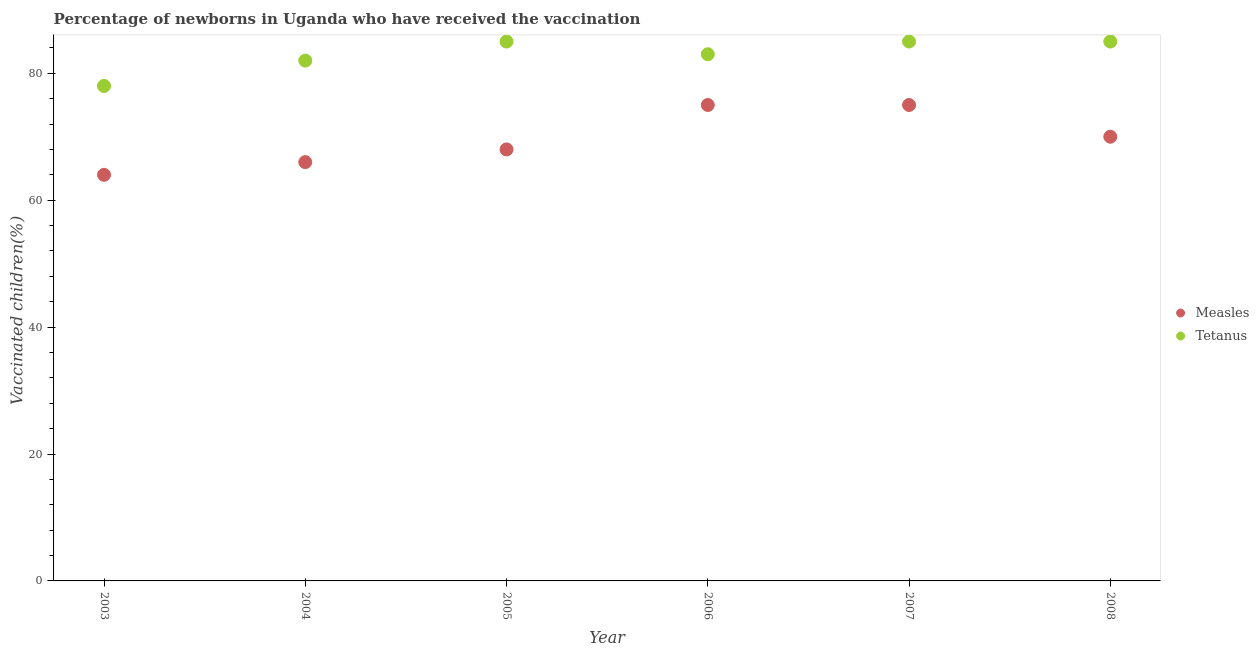How many different coloured dotlines are there?
Ensure brevity in your answer.  2. Is the number of dotlines equal to the number of legend labels?
Ensure brevity in your answer.  Yes. What is the percentage of newborns who received vaccination for tetanus in 2008?
Give a very brief answer. 85. Across all years, what is the maximum percentage of newborns who received vaccination for tetanus?
Offer a terse response. 85. Across all years, what is the minimum percentage of newborns who received vaccination for tetanus?
Offer a very short reply. 78. In which year was the percentage of newborns who received vaccination for measles maximum?
Your answer should be compact. 2006. What is the total percentage of newborns who received vaccination for tetanus in the graph?
Your answer should be compact. 498. What is the difference between the percentage of newborns who received vaccination for measles in 2003 and that in 2005?
Offer a very short reply. -4. What is the difference between the percentage of newborns who received vaccination for measles in 2003 and the percentage of newborns who received vaccination for tetanus in 2006?
Make the answer very short. -19. What is the average percentage of newborns who received vaccination for measles per year?
Make the answer very short. 69.67. In the year 2006, what is the difference between the percentage of newborns who received vaccination for measles and percentage of newborns who received vaccination for tetanus?
Make the answer very short. -8. In how many years, is the percentage of newborns who received vaccination for tetanus greater than 76 %?
Your answer should be very brief. 6. What is the ratio of the percentage of newborns who received vaccination for measles in 2007 to that in 2008?
Your answer should be compact. 1.07. What is the difference between the highest and the second highest percentage of newborns who received vaccination for measles?
Provide a succinct answer. 0. What is the difference between the highest and the lowest percentage of newborns who received vaccination for measles?
Provide a short and direct response. 11. In how many years, is the percentage of newborns who received vaccination for tetanus greater than the average percentage of newborns who received vaccination for tetanus taken over all years?
Keep it short and to the point. 3. Does the percentage of newborns who received vaccination for tetanus monotonically increase over the years?
Ensure brevity in your answer.  No. Is the percentage of newborns who received vaccination for measles strictly greater than the percentage of newborns who received vaccination for tetanus over the years?
Ensure brevity in your answer.  No. Is the percentage of newborns who received vaccination for tetanus strictly less than the percentage of newborns who received vaccination for measles over the years?
Your answer should be compact. No. How many years are there in the graph?
Offer a terse response. 6. Does the graph contain any zero values?
Keep it short and to the point. No. Does the graph contain grids?
Keep it short and to the point. No. How many legend labels are there?
Ensure brevity in your answer.  2. What is the title of the graph?
Give a very brief answer. Percentage of newborns in Uganda who have received the vaccination. Does "Private consumption" appear as one of the legend labels in the graph?
Make the answer very short. No. What is the label or title of the X-axis?
Keep it short and to the point. Year. What is the label or title of the Y-axis?
Keep it short and to the point. Vaccinated children(%)
. What is the Vaccinated children(%)
 in Measles in 2003?
Ensure brevity in your answer.  64. What is the Vaccinated children(%)
 in Tetanus in 2003?
Make the answer very short. 78. What is the Vaccinated children(%)
 of Measles in 2004?
Your answer should be very brief. 66. What is the Vaccinated children(%)
 in Measles in 2006?
Keep it short and to the point. 75. Across all years, what is the maximum Vaccinated children(%)
 of Measles?
Provide a short and direct response. 75. Across all years, what is the minimum Vaccinated children(%)
 of Measles?
Ensure brevity in your answer.  64. What is the total Vaccinated children(%)
 of Measles in the graph?
Keep it short and to the point. 418. What is the total Vaccinated children(%)
 in Tetanus in the graph?
Offer a terse response. 498. What is the difference between the Vaccinated children(%)
 in Measles in 2003 and that in 2005?
Offer a terse response. -4. What is the difference between the Vaccinated children(%)
 in Tetanus in 2003 and that in 2005?
Offer a very short reply. -7. What is the difference between the Vaccinated children(%)
 in Measles in 2003 and that in 2006?
Your response must be concise. -11. What is the difference between the Vaccinated children(%)
 of Measles in 2003 and that in 2007?
Make the answer very short. -11. What is the difference between the Vaccinated children(%)
 in Tetanus in 2003 and that in 2007?
Your answer should be very brief. -7. What is the difference between the Vaccinated children(%)
 in Measles in 2003 and that in 2008?
Give a very brief answer. -6. What is the difference between the Vaccinated children(%)
 of Tetanus in 2003 and that in 2008?
Provide a succinct answer. -7. What is the difference between the Vaccinated children(%)
 in Measles in 2004 and that in 2005?
Your response must be concise. -2. What is the difference between the Vaccinated children(%)
 in Measles in 2004 and that in 2007?
Ensure brevity in your answer.  -9. What is the difference between the Vaccinated children(%)
 of Tetanus in 2004 and that in 2007?
Make the answer very short. -3. What is the difference between the Vaccinated children(%)
 in Tetanus in 2004 and that in 2008?
Make the answer very short. -3. What is the difference between the Vaccinated children(%)
 of Measles in 2005 and that in 2006?
Make the answer very short. -7. What is the difference between the Vaccinated children(%)
 in Tetanus in 2005 and that in 2007?
Your response must be concise. 0. What is the difference between the Vaccinated children(%)
 of Tetanus in 2006 and that in 2007?
Your response must be concise. -2. What is the difference between the Vaccinated children(%)
 in Measles in 2006 and that in 2008?
Provide a succinct answer. 5. What is the difference between the Vaccinated children(%)
 of Measles in 2007 and that in 2008?
Your response must be concise. 5. What is the difference between the Vaccinated children(%)
 in Measles in 2003 and the Vaccinated children(%)
 in Tetanus in 2004?
Make the answer very short. -18. What is the difference between the Vaccinated children(%)
 of Measles in 2003 and the Vaccinated children(%)
 of Tetanus in 2005?
Give a very brief answer. -21. What is the difference between the Vaccinated children(%)
 of Measles in 2003 and the Vaccinated children(%)
 of Tetanus in 2006?
Keep it short and to the point. -19. What is the difference between the Vaccinated children(%)
 in Measles in 2003 and the Vaccinated children(%)
 in Tetanus in 2007?
Make the answer very short. -21. What is the difference between the Vaccinated children(%)
 of Measles in 2003 and the Vaccinated children(%)
 of Tetanus in 2008?
Provide a short and direct response. -21. What is the difference between the Vaccinated children(%)
 in Measles in 2004 and the Vaccinated children(%)
 in Tetanus in 2005?
Offer a terse response. -19. What is the difference between the Vaccinated children(%)
 in Measles in 2004 and the Vaccinated children(%)
 in Tetanus in 2006?
Your response must be concise. -17. What is the difference between the Vaccinated children(%)
 of Measles in 2005 and the Vaccinated children(%)
 of Tetanus in 2006?
Offer a very short reply. -15. What is the difference between the Vaccinated children(%)
 of Measles in 2005 and the Vaccinated children(%)
 of Tetanus in 2008?
Offer a terse response. -17. What is the difference between the Vaccinated children(%)
 in Measles in 2006 and the Vaccinated children(%)
 in Tetanus in 2008?
Offer a terse response. -10. What is the difference between the Vaccinated children(%)
 of Measles in 2007 and the Vaccinated children(%)
 of Tetanus in 2008?
Give a very brief answer. -10. What is the average Vaccinated children(%)
 in Measles per year?
Give a very brief answer. 69.67. In the year 2008, what is the difference between the Vaccinated children(%)
 in Measles and Vaccinated children(%)
 in Tetanus?
Give a very brief answer. -15. What is the ratio of the Vaccinated children(%)
 of Measles in 2003 to that in 2004?
Keep it short and to the point. 0.97. What is the ratio of the Vaccinated children(%)
 in Tetanus in 2003 to that in 2004?
Keep it short and to the point. 0.95. What is the ratio of the Vaccinated children(%)
 in Measles in 2003 to that in 2005?
Your response must be concise. 0.94. What is the ratio of the Vaccinated children(%)
 in Tetanus in 2003 to that in 2005?
Offer a terse response. 0.92. What is the ratio of the Vaccinated children(%)
 of Measles in 2003 to that in 2006?
Give a very brief answer. 0.85. What is the ratio of the Vaccinated children(%)
 in Tetanus in 2003 to that in 2006?
Offer a terse response. 0.94. What is the ratio of the Vaccinated children(%)
 of Measles in 2003 to that in 2007?
Your response must be concise. 0.85. What is the ratio of the Vaccinated children(%)
 in Tetanus in 2003 to that in 2007?
Give a very brief answer. 0.92. What is the ratio of the Vaccinated children(%)
 in Measles in 2003 to that in 2008?
Make the answer very short. 0.91. What is the ratio of the Vaccinated children(%)
 of Tetanus in 2003 to that in 2008?
Your answer should be very brief. 0.92. What is the ratio of the Vaccinated children(%)
 in Measles in 2004 to that in 2005?
Offer a very short reply. 0.97. What is the ratio of the Vaccinated children(%)
 of Tetanus in 2004 to that in 2005?
Give a very brief answer. 0.96. What is the ratio of the Vaccinated children(%)
 of Measles in 2004 to that in 2006?
Your answer should be very brief. 0.88. What is the ratio of the Vaccinated children(%)
 of Measles in 2004 to that in 2007?
Keep it short and to the point. 0.88. What is the ratio of the Vaccinated children(%)
 in Tetanus in 2004 to that in 2007?
Make the answer very short. 0.96. What is the ratio of the Vaccinated children(%)
 in Measles in 2004 to that in 2008?
Offer a terse response. 0.94. What is the ratio of the Vaccinated children(%)
 of Tetanus in 2004 to that in 2008?
Your answer should be compact. 0.96. What is the ratio of the Vaccinated children(%)
 of Measles in 2005 to that in 2006?
Your answer should be compact. 0.91. What is the ratio of the Vaccinated children(%)
 in Tetanus in 2005 to that in 2006?
Keep it short and to the point. 1.02. What is the ratio of the Vaccinated children(%)
 of Measles in 2005 to that in 2007?
Your answer should be compact. 0.91. What is the ratio of the Vaccinated children(%)
 in Measles in 2005 to that in 2008?
Offer a terse response. 0.97. What is the ratio of the Vaccinated children(%)
 of Tetanus in 2006 to that in 2007?
Keep it short and to the point. 0.98. What is the ratio of the Vaccinated children(%)
 in Measles in 2006 to that in 2008?
Offer a terse response. 1.07. What is the ratio of the Vaccinated children(%)
 of Tetanus in 2006 to that in 2008?
Your answer should be compact. 0.98. What is the ratio of the Vaccinated children(%)
 in Measles in 2007 to that in 2008?
Your response must be concise. 1.07. What is the ratio of the Vaccinated children(%)
 in Tetanus in 2007 to that in 2008?
Make the answer very short. 1. What is the difference between the highest and the second highest Vaccinated children(%)
 of Tetanus?
Your answer should be compact. 0. What is the difference between the highest and the lowest Vaccinated children(%)
 of Measles?
Make the answer very short. 11. 